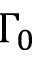Convert formula to latex. <formula><loc_0><loc_0><loc_500><loc_500>\Gamma _ { 0 }</formula> 